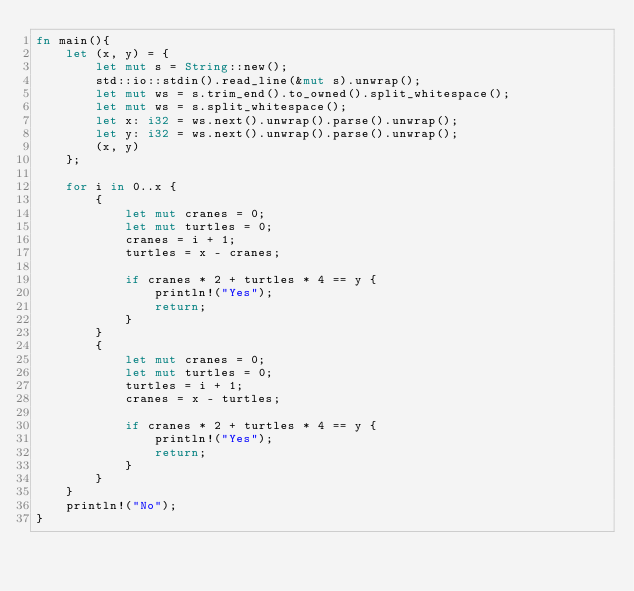<code> <loc_0><loc_0><loc_500><loc_500><_Rust_>fn main(){
    let (x, y) = {
        let mut s = String::new();
        std::io::stdin().read_line(&mut s).unwrap();
        let mut ws = s.trim_end().to_owned().split_whitespace();
        let mut ws = s.split_whitespace();
        let x: i32 = ws.next().unwrap().parse().unwrap();
        let y: i32 = ws.next().unwrap().parse().unwrap();
        (x, y)
    };

    for i in 0..x {
        {
            let mut cranes = 0;
            let mut turtles = 0;
            cranes = i + 1;
            turtles = x - cranes;

            if cranes * 2 + turtles * 4 == y {
                println!("Yes");
                return;
            }
        }
        {
            let mut cranes = 0;
            let mut turtles = 0;
            turtles = i + 1;
            cranes = x - turtles;

            if cranes * 2 + turtles * 4 == y {
                println!("Yes");
                return;
            }
        }
    }
    println!("No");
}
</code> 